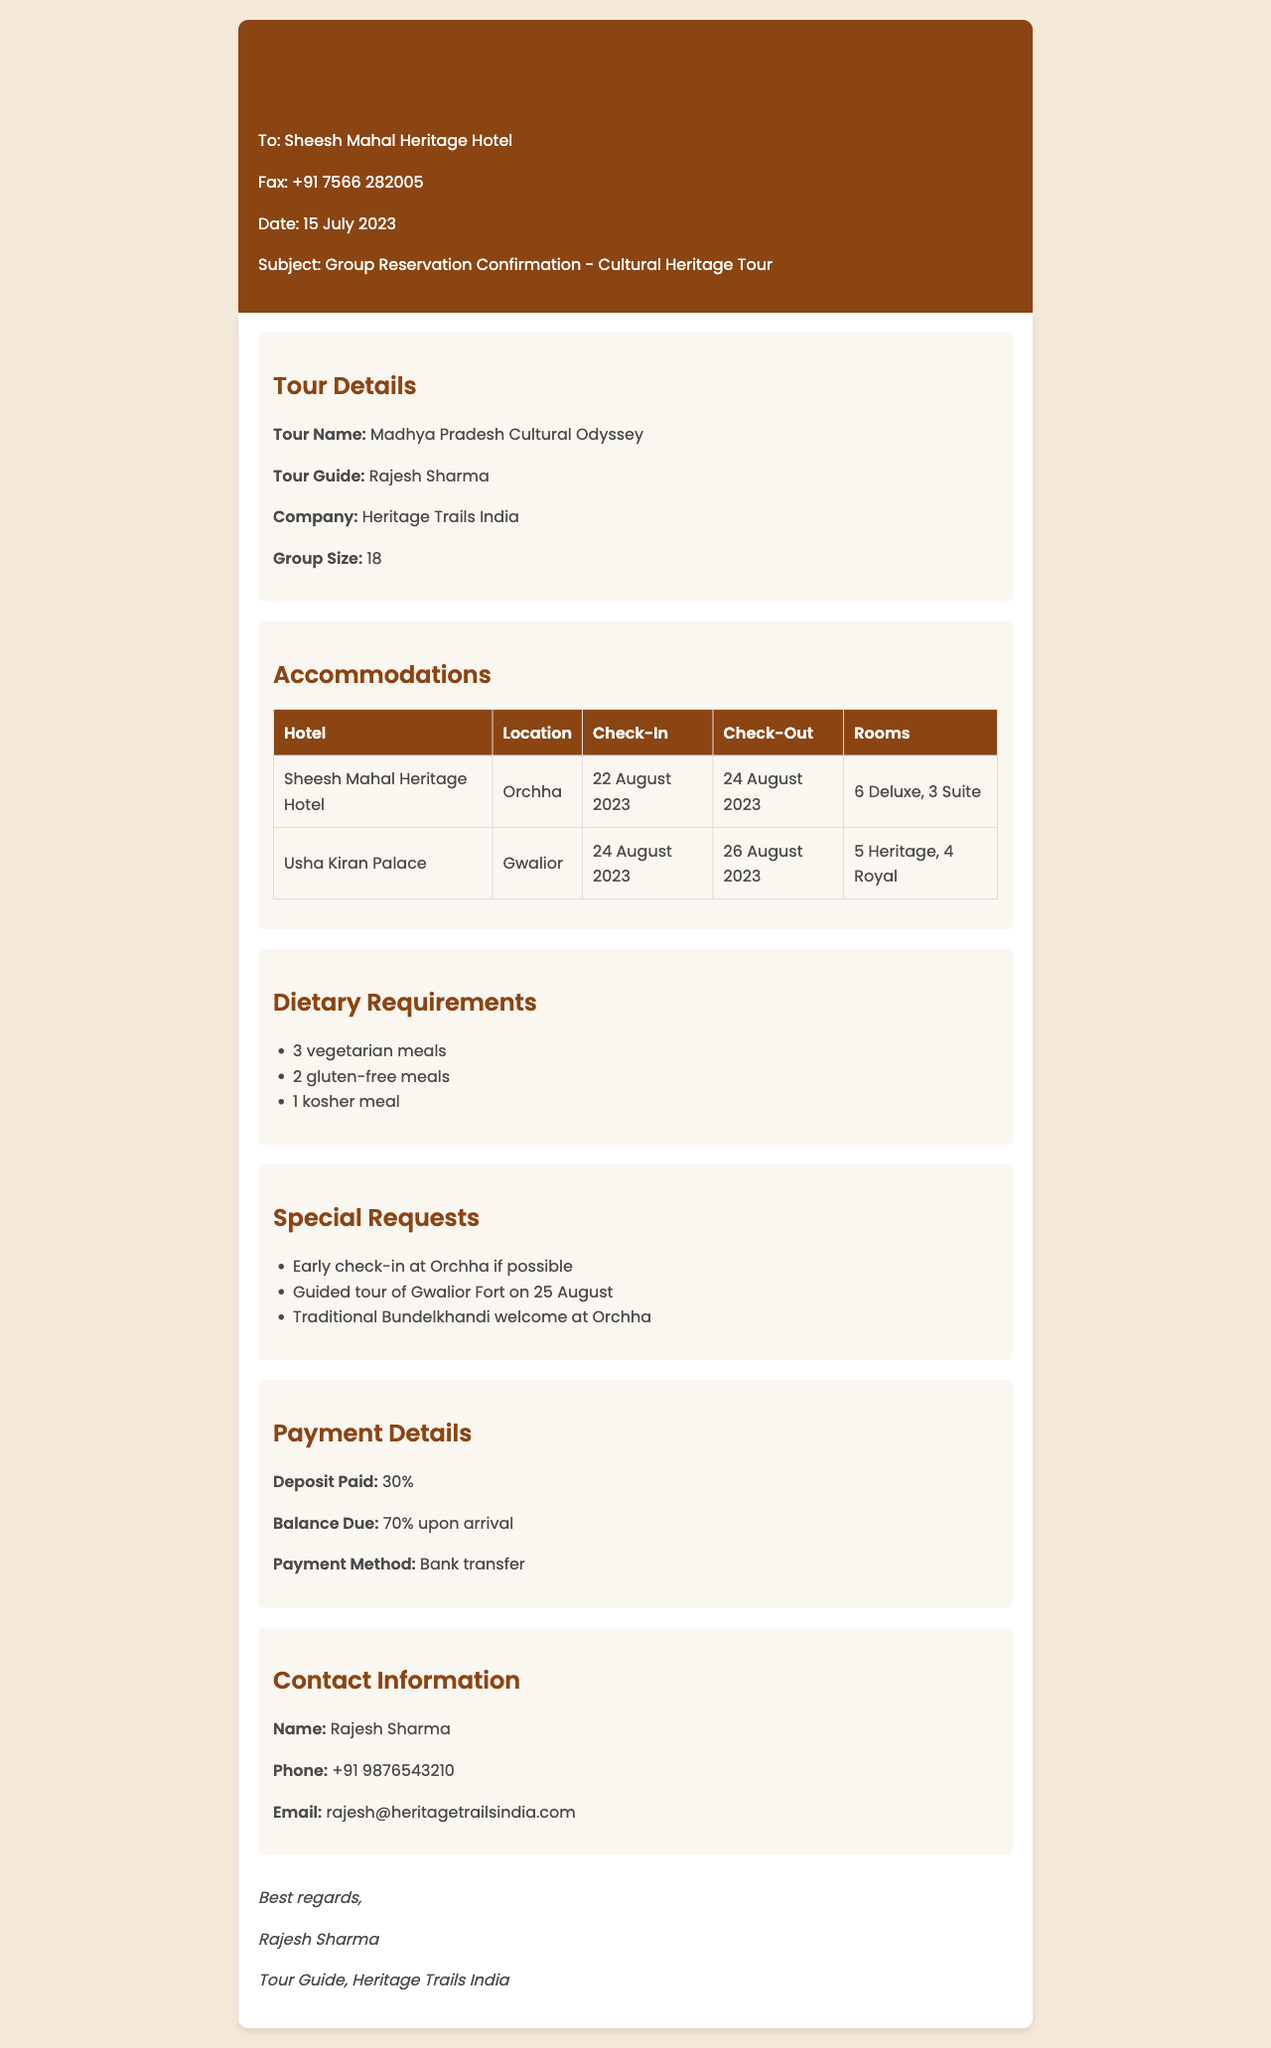What is the tour name? The tour name is specified in the document as "Madhya Pradesh Cultural Odyssey."
Answer: Madhya Pradesh Cultural Odyssey What is the group size? The group size is mentioned in the document under the tour details section, which states there are 18 members.
Answer: 18 What hotels are reserved for the group? The hotels listed in the accommodations section include Sheesh Mahal Heritage Hotel and Usha Kiran Palace.
Answer: Sheesh Mahal Heritage Hotel, Usha Kiran Palace What is the check-in date at Orchha? The check-in date for Sheesh Mahal Heritage Hotel in Orchha is noted in the accommodations table as 22 August 2023.
Answer: 22 August 2023 How many vegetarian meals are required? The dietary section specifies the need for 3 vegetarian meals for the group.
Answer: 3 vegetarian meals What special request is related to Gwalior Fort? The document mentions a request for a guided tour of Gwalior Fort on 25 August, indicating the group's interest in this site.
Answer: Guided tour of Gwalior Fort on 25 August What percentage of the total cost is the deposit? The document outlines that a deposit of 30% has been paid for the reservation.
Answer: 30% Who is the tour guide? The name of the tour guide is provided in the tour details section as Rajesh Sharma.
Answer: Rajesh Sharma What is the payment method listed? The payment method is indicated in the payment details section as a bank transfer.
Answer: Bank transfer 